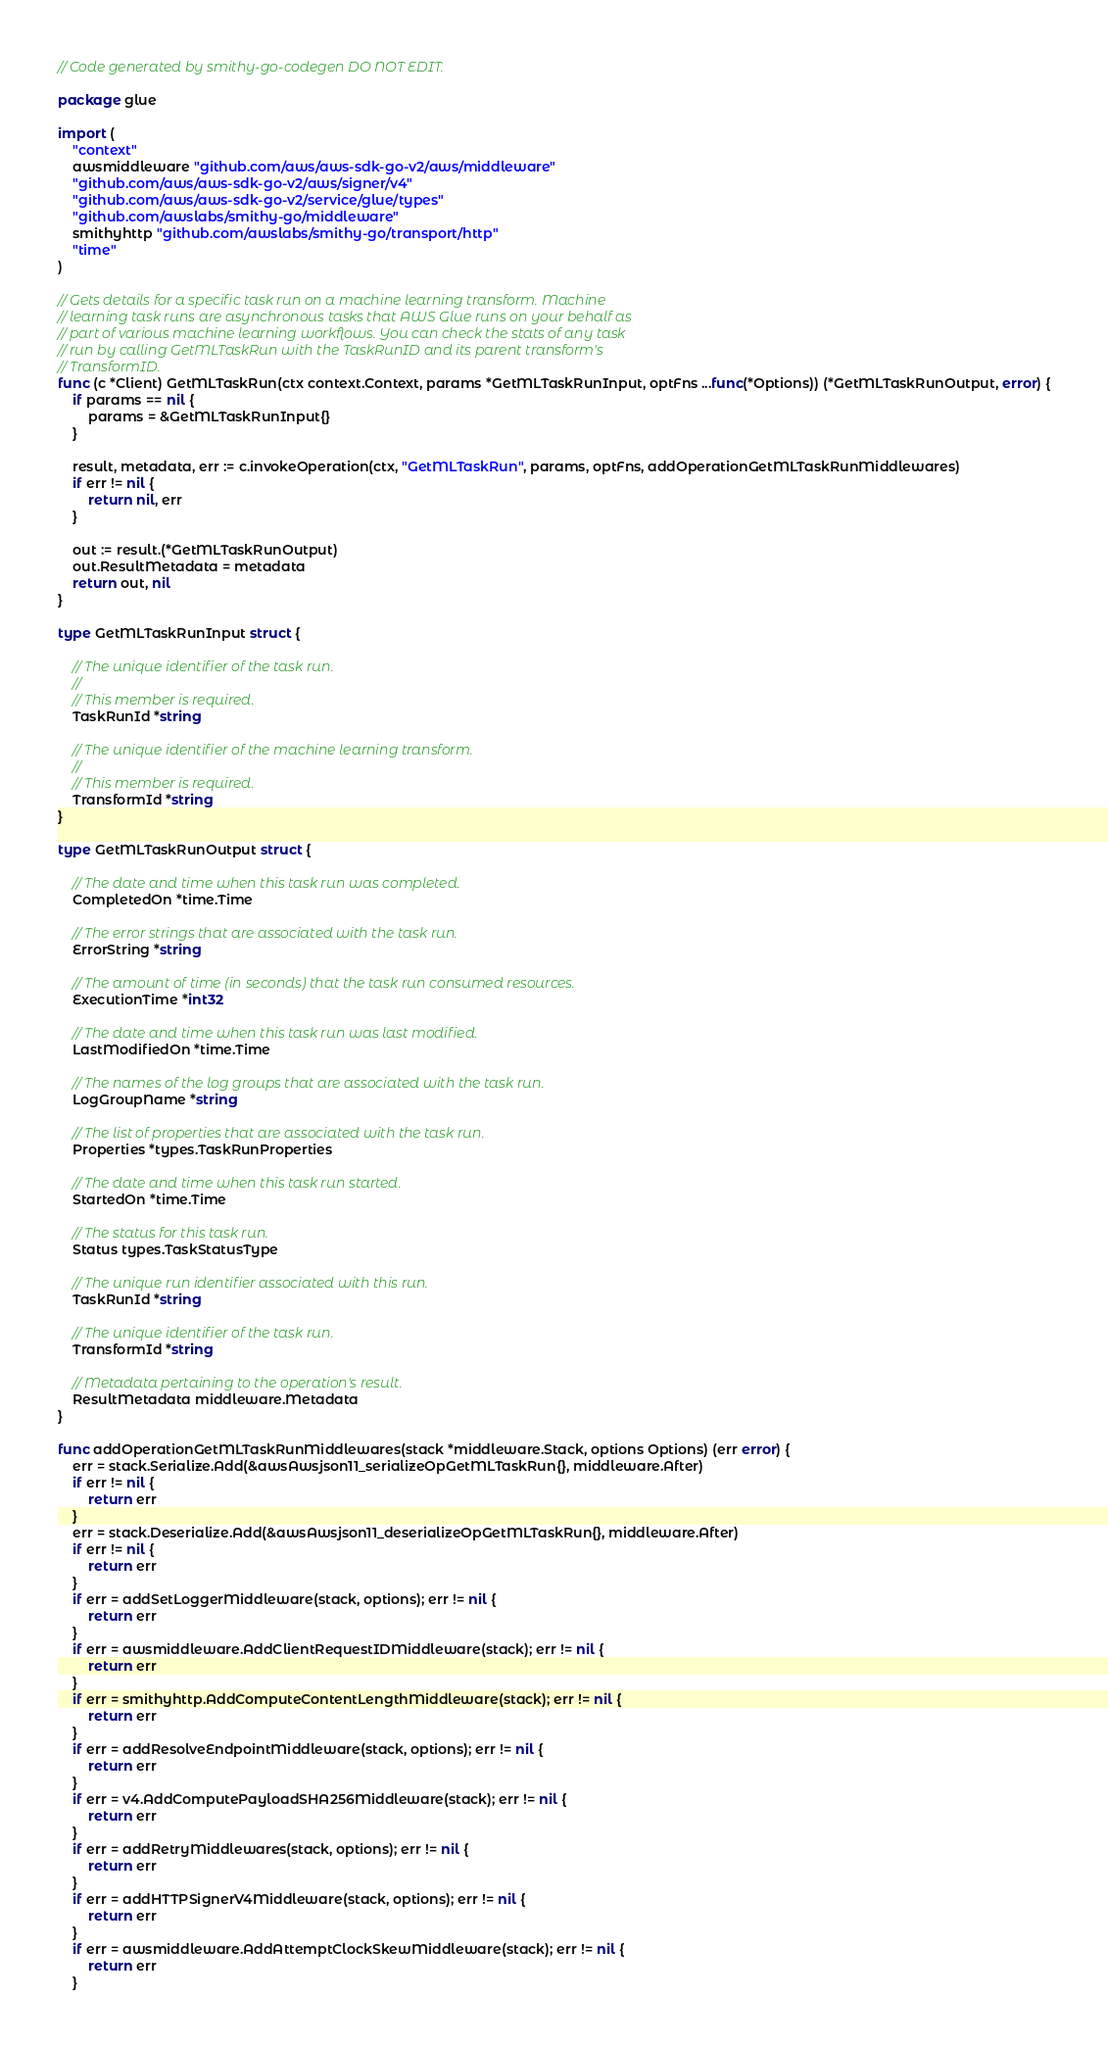Convert code to text. <code><loc_0><loc_0><loc_500><loc_500><_Go_>// Code generated by smithy-go-codegen DO NOT EDIT.

package glue

import (
	"context"
	awsmiddleware "github.com/aws/aws-sdk-go-v2/aws/middleware"
	"github.com/aws/aws-sdk-go-v2/aws/signer/v4"
	"github.com/aws/aws-sdk-go-v2/service/glue/types"
	"github.com/awslabs/smithy-go/middleware"
	smithyhttp "github.com/awslabs/smithy-go/transport/http"
	"time"
)

// Gets details for a specific task run on a machine learning transform. Machine
// learning task runs are asynchronous tasks that AWS Glue runs on your behalf as
// part of various machine learning workflows. You can check the stats of any task
// run by calling GetMLTaskRun with the TaskRunID and its parent transform's
// TransformID.
func (c *Client) GetMLTaskRun(ctx context.Context, params *GetMLTaskRunInput, optFns ...func(*Options)) (*GetMLTaskRunOutput, error) {
	if params == nil {
		params = &GetMLTaskRunInput{}
	}

	result, metadata, err := c.invokeOperation(ctx, "GetMLTaskRun", params, optFns, addOperationGetMLTaskRunMiddlewares)
	if err != nil {
		return nil, err
	}

	out := result.(*GetMLTaskRunOutput)
	out.ResultMetadata = metadata
	return out, nil
}

type GetMLTaskRunInput struct {

	// The unique identifier of the task run.
	//
	// This member is required.
	TaskRunId *string

	// The unique identifier of the machine learning transform.
	//
	// This member is required.
	TransformId *string
}

type GetMLTaskRunOutput struct {

	// The date and time when this task run was completed.
	CompletedOn *time.Time

	// The error strings that are associated with the task run.
	ErrorString *string

	// The amount of time (in seconds) that the task run consumed resources.
	ExecutionTime *int32

	// The date and time when this task run was last modified.
	LastModifiedOn *time.Time

	// The names of the log groups that are associated with the task run.
	LogGroupName *string

	// The list of properties that are associated with the task run.
	Properties *types.TaskRunProperties

	// The date and time when this task run started.
	StartedOn *time.Time

	// The status for this task run.
	Status types.TaskStatusType

	// The unique run identifier associated with this run.
	TaskRunId *string

	// The unique identifier of the task run.
	TransformId *string

	// Metadata pertaining to the operation's result.
	ResultMetadata middleware.Metadata
}

func addOperationGetMLTaskRunMiddlewares(stack *middleware.Stack, options Options) (err error) {
	err = stack.Serialize.Add(&awsAwsjson11_serializeOpGetMLTaskRun{}, middleware.After)
	if err != nil {
		return err
	}
	err = stack.Deserialize.Add(&awsAwsjson11_deserializeOpGetMLTaskRun{}, middleware.After)
	if err != nil {
		return err
	}
	if err = addSetLoggerMiddleware(stack, options); err != nil {
		return err
	}
	if err = awsmiddleware.AddClientRequestIDMiddleware(stack); err != nil {
		return err
	}
	if err = smithyhttp.AddComputeContentLengthMiddleware(stack); err != nil {
		return err
	}
	if err = addResolveEndpointMiddleware(stack, options); err != nil {
		return err
	}
	if err = v4.AddComputePayloadSHA256Middleware(stack); err != nil {
		return err
	}
	if err = addRetryMiddlewares(stack, options); err != nil {
		return err
	}
	if err = addHTTPSignerV4Middleware(stack, options); err != nil {
		return err
	}
	if err = awsmiddleware.AddAttemptClockSkewMiddleware(stack); err != nil {
		return err
	}</code> 